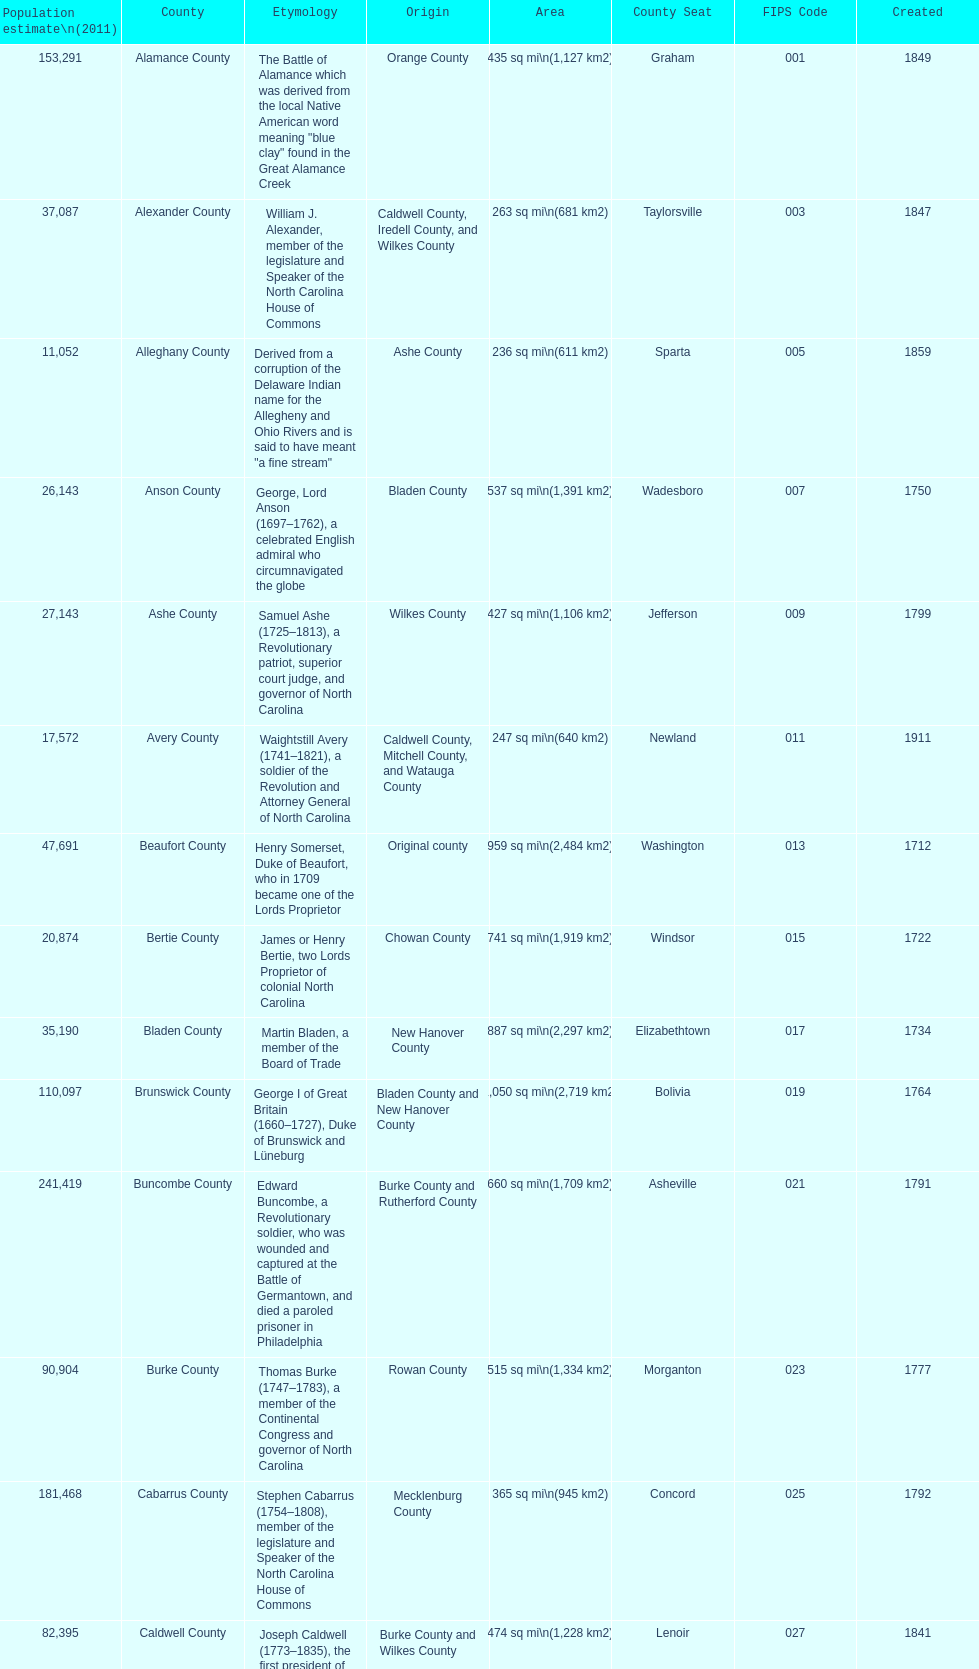Other than mecklenburg which county has the largest population? Wake County. 